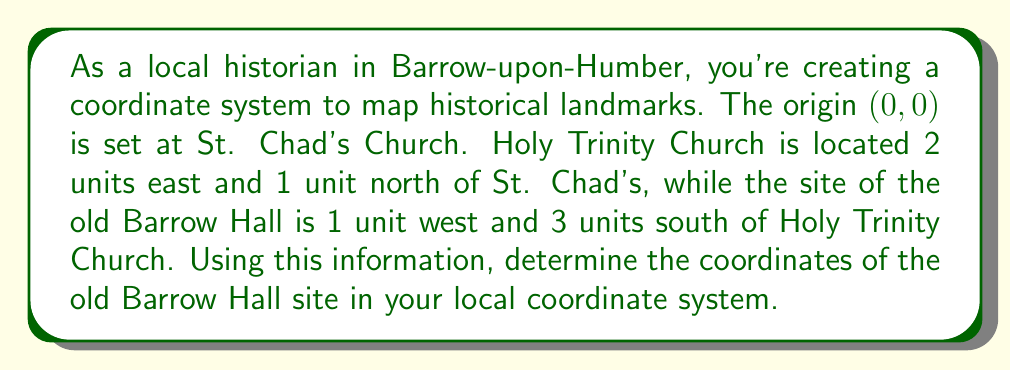Solve this math problem. Let's approach this step-by-step:

1) First, let's establish the coordinates we know:
   - St. Chad's Church is at (0,0)
   - Holy Trinity Church is 2 units east and 1 unit north of St. Chad's, so its coordinates are (2,1)

2) Now, we need to find the coordinates of the old Barrow Hall site. We know it's 1 unit west and 3 units south of Holy Trinity Church.

3) To move west, we subtract from the x-coordinate. To move south, we subtract from the y-coordinate.

4) So, from Holy Trinity Church (2,1), we need to:
   - Subtract 1 from the x-coordinate: $2 - 1 = 1$
   - Subtract 3 from the y-coordinate: $1 - 3 = -2$

5) Therefore, the coordinates of the old Barrow Hall site are (1,-2)

We can verify this by calculating the vector from St. Chad's Church to the old Barrow Hall site:
$$\vec{v} = (1,-2) - (0,0) = (1,-2)$$

This vector indeed represents 1 unit east and 2 units south of St. Chad's Church, which matches our derived location for the old Barrow Hall site.
Answer: The coordinates of the old Barrow Hall site in the local coordinate system are (1,-2). 